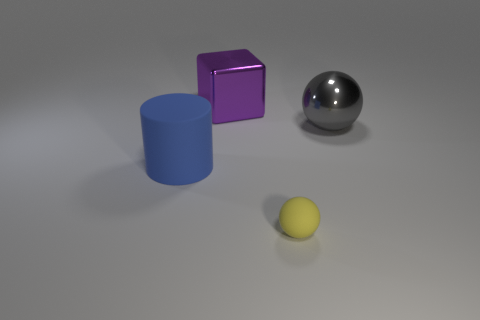Does the sphere on the left side of the gray ball have the same material as the large block?
Your response must be concise. No. How many other things are there of the same material as the large purple thing?
Your response must be concise. 1. What number of objects are things that are left of the large purple object or shiny objects that are to the right of the yellow thing?
Your answer should be compact. 2. Is the shape of the metal thing to the left of the big sphere the same as the rubber thing in front of the large rubber cylinder?
Give a very brief answer. No. The gray shiny thing that is the same size as the blue rubber cylinder is what shape?
Provide a succinct answer. Sphere. What number of metal things are either big green cylinders or cylinders?
Ensure brevity in your answer.  0. Does the big object left of the purple thing have the same material as the large purple object that is behind the blue thing?
Offer a very short reply. No. What is the color of the other object that is made of the same material as the big blue object?
Keep it short and to the point. Yellow. Is the number of tiny yellow matte things right of the big cylinder greater than the number of gray shiny objects that are behind the big purple object?
Your answer should be very brief. Yes. Is there a small thing?
Keep it short and to the point. Yes. 